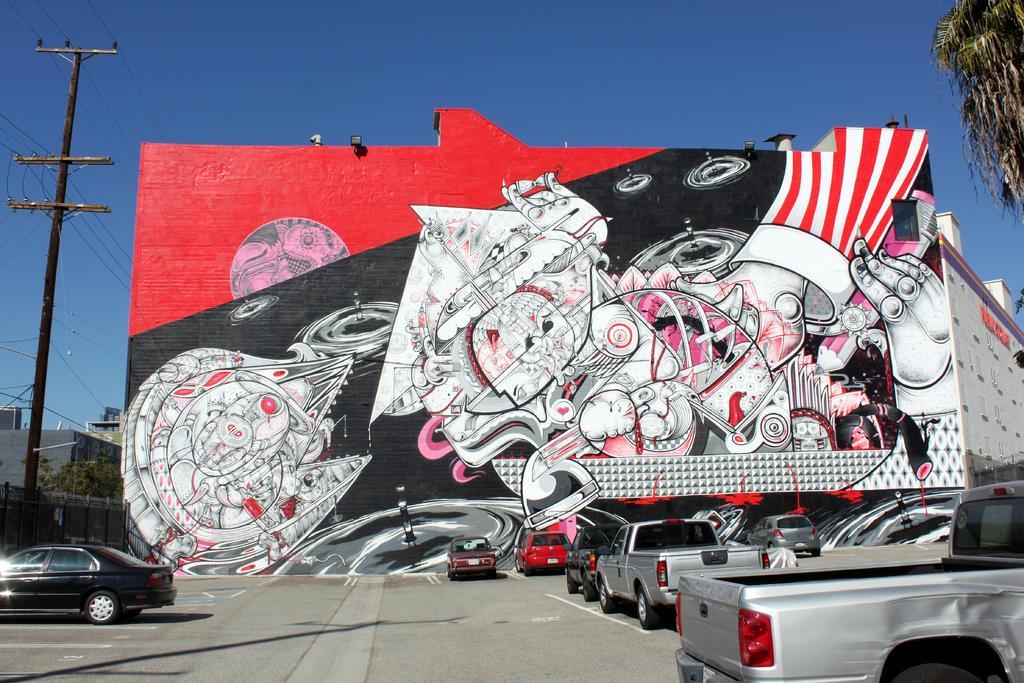Describe this image in one or two sentences. In this image there is some graffiti and lights on the wall, there are few buildings, few vehicles on the road, few trees, a fence and the sky. 